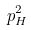<formula> <loc_0><loc_0><loc_500><loc_500>p _ { H } ^ { 2 }</formula> 